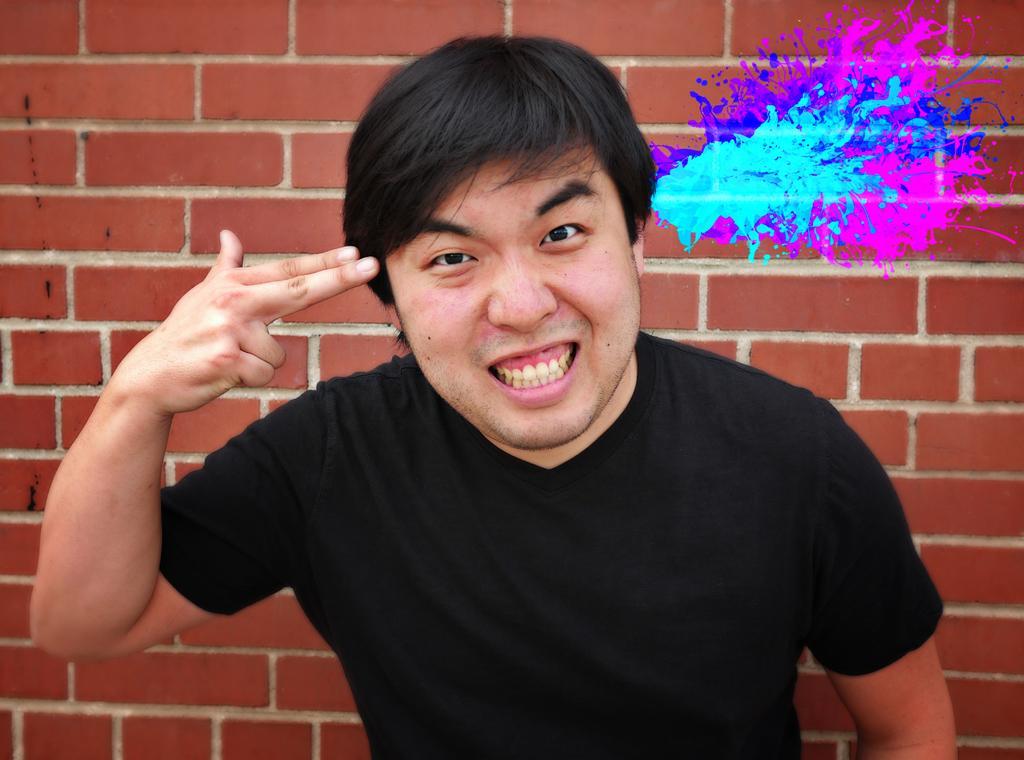How would you summarize this image in a sentence or two? In this image we can see a man. He is wearing a black color T-shirt and he is pointing out two fingers of his hand towards his head. In the background, we can see the brick wall. Here we can see the color paint on the wall on the right side. 